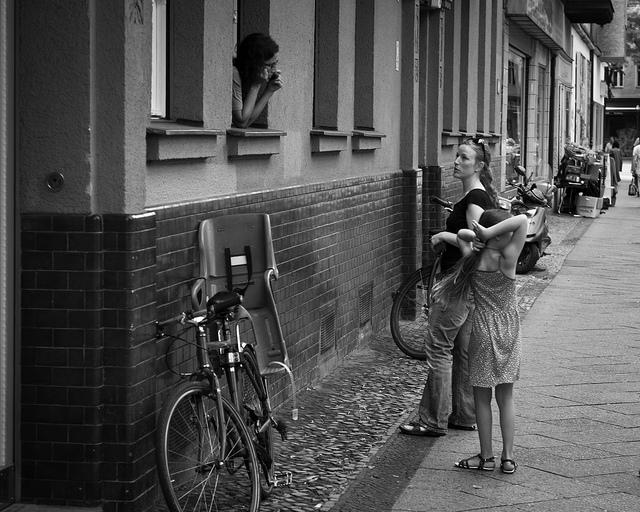The owner of the nearest Bicycle here has which role?

Choices:
A) robber
B) prisoner
C) page
D) parent parent 